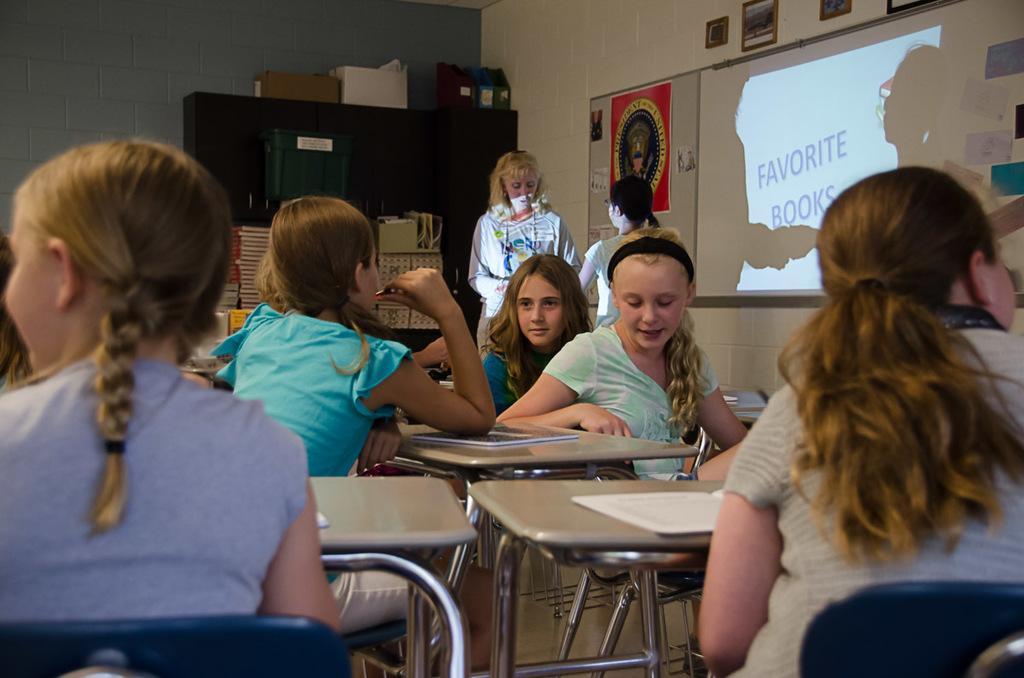Please provide a concise description of this image. In this image we can see this people are sitting on the chairs. In the background we can see projector screen on wall. 